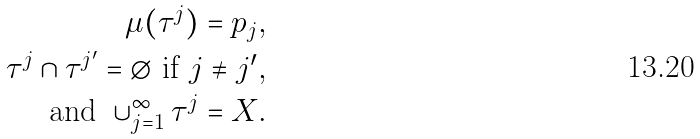Convert formula to latex. <formula><loc_0><loc_0><loc_500><loc_500>\mu ( \tau ^ { j } ) = p _ { j } , \\ \tau ^ { j } \cap \tau ^ { j ^ { \prime } } = \emptyset \text { if } j \neq j ^ { \prime } , \\ \text {and } \cup _ { j = 1 } ^ { \infty } \tau ^ { j } = X .</formula> 